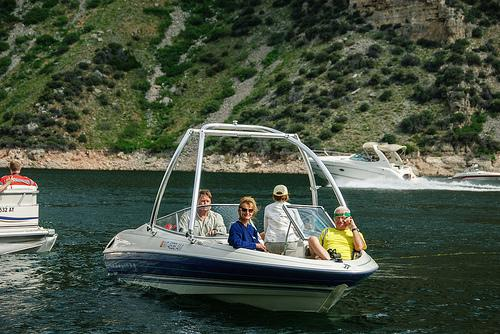Utilize vivid language to illustrate the primary components of the image. The sun reflects off the lively, green water as four vibrant vessels, carrying enthusiastic passengers, navigate the river alongside a lush, verdant shoreline. Write a descriptive sentence of the primary scene in the image. A group of four people are enjoying a boat ride on a green river, surrounded by rocky shoreline and a hill covered with vegetation. Identify the main elements in the image and their relationship to one another. The image features four boats with people onboard, gliding across calm river water, creating a wake as they pass the hilly, green shoreline. In one sentence, describe the primary action taking place in the image. Four people, including a man in a yellow shirt, are riding in a motorboat that creates a wake in the water as it speeds past the rocky shore. Explain the visual focus of the image and what it conveys. The main focus is on the four people in the boat, enjoying their time on the water, showcasing the excitement and camaraderie of a boat ride. Depict the atmosphere and key actions occurring in the image using sensory language. Picture the gentle lapping of water as four boats glide along the tranquil river, their wakes rippling against the rugged, rocky shoreline and the scent of fresh, green foliage fills the air. Summarize the overall atmosphere and setting of the image. This image portrays a joyful, leisurely scene of friends on a boating trip in a peaceful, natural landscape. Describe any specific clothing items or distinctive features of the people in the image. Notable clothing items in this image include a man in a yellow shirt and shorts, two women wearing blue apparel, and one of them donning a baseball cap. Mention the most prominent colors in the image and their associations with particular subjects. The image highlights the yellow shirt of a man, the blue shirt and cap of two women, the green water and foliage, and the white boats. Express the setting and main activity in the image using an informal tone. It's a chill scene with a group of friends cruising on boats, having a blast on the greenish river, and enjoying a nice day by the green, hilly shore. 